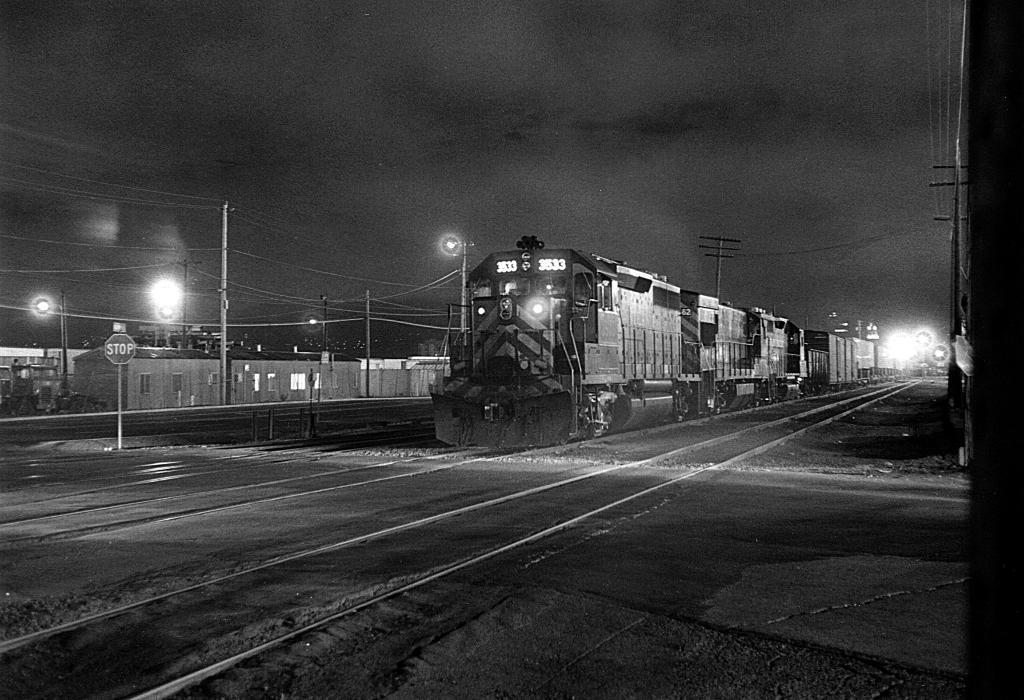How would you summarize this image in a sentence or two? In this image I can see the black and white picture in which I can see the ground, few railway tracks, a train on the track, few trees, few buildings, few poles, few boards, few lights and the sky in the background. 